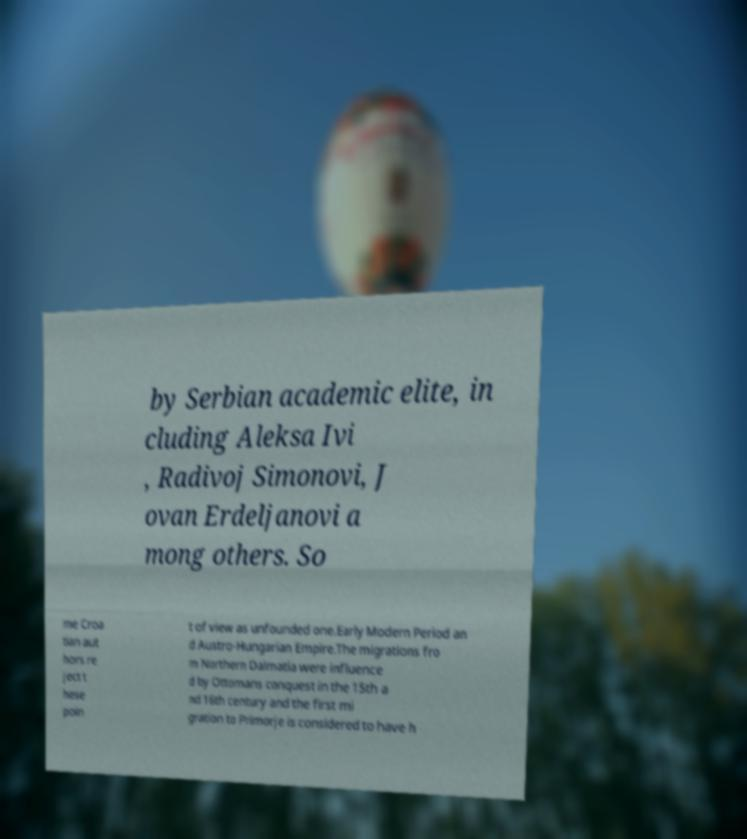Could you assist in decoding the text presented in this image and type it out clearly? by Serbian academic elite, in cluding Aleksa Ivi , Radivoj Simonovi, J ovan Erdeljanovi a mong others. So me Croa tian aut hors re ject t hese poin t of view as unfounded one.Early Modern Period an d Austro-Hungarian Empire.The migrations fro m Northern Dalmatia were influence d by Ottomans conquest in the 15th a nd 16th century and the first mi gration to Primorje is considered to have h 